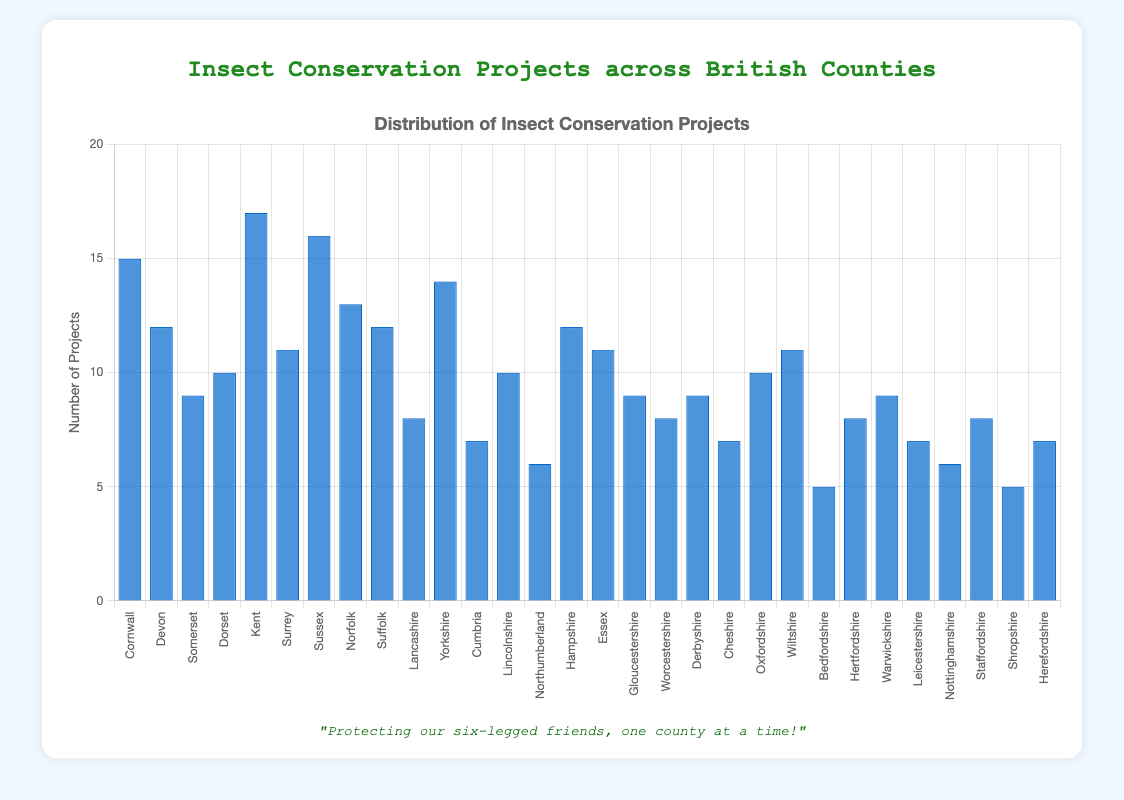Which county has the most insect conservation projects? Looking at the heights of the blue bars, Kent has the tallest bar, indicating it has the most projects.
Answer: Kent Which county has the fewest insect conservation projects? The bar for Bedfordshire is the shortest compared to the rest, which means it has the fewest projects.
Answer: Bedfordshire Which counties have more than 15 insect conservation projects? By checking the bars taller than the 15 mark, only Kent (17) and Sussex (16) fit this criterion.
Answer: Kent, Sussex What is the total number of insect conservation projects in Devon and Cornwall combined? Adding the projects from Devon and Cornwall: 12 (Devon) + 15 (Cornwall) = 27.
Answer: 27 How many counties have exactly 10 insect conservation projects? There are bars at the height corresponding to 10 for Dorset, Lincolnshire, and Oxfordshire. By counting these, the result is 3 counties.
Answer: 3 Which counties have more projects: Norfolk or Hampshire? Comparing the heights of the bars for Norfolk and Hampshire, Norfolk has 13 projects while Hampshire has 12 projects. Norfolk thus has more.
Answer: Norfolk What is the range of insect conservation projects among the counties? The range is calculated by subtracting the fewest projects (5 in Bedfordshire) from the most projects (17 in Kent). So, 17 - 5 = 12.
Answer: 12 What is the difference in the number of projects between Sussex and Dorset? Sussex has 16 projects, Dorset has 10. Subtracting these gives 16 - 10 = 6.
Answer: 6 Which counties have exactly 7 insect conservation projects? The bars corresponding to 7 projects are for Cumbria, Cheshire, Leicestershire, and Herefordshire.
Answer: Cumbria, Cheshire, Leicestershire, Herefordshire Calculate the average number of insect conservation projects per county. Sum all the project values and divide by the number of counties. Total projects: 15 + 12 + 9 + 10 + 17 + 11 + 16 + 13 + 12 + 8 + 14 + 7 + 10 + 6 + 12 + 11 + 9 + 8 + 9 + 7 + 10 + 11 + 5 + 8 + 9 + 7 + 6 + 8 + 5 + 7 = 270. Number of counties is 30. The average is 270 / 30 = 9.
Answer: 9 